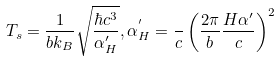Convert formula to latex. <formula><loc_0><loc_0><loc_500><loc_500>T _ { s } = \frac { 1 } { b k _ { B } } \sqrt { \frac { \hbar { c } ^ { 3 } } { \alpha ^ { \prime } _ { H } } } , \alpha ^ { ^ { \prime } } _ { H } = \frac { } { c } \left ( \frac { 2 \pi } { b } \frac { H \alpha ^ { \prime } } { c } \right ) ^ { 2 }</formula> 